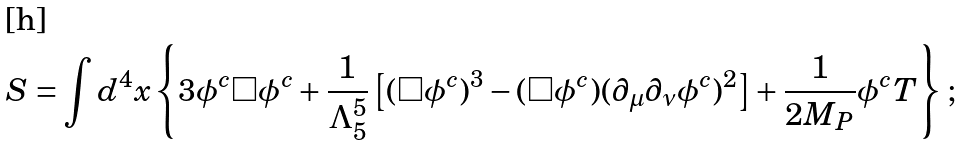<formula> <loc_0><loc_0><loc_500><loc_500>S = \int d ^ { 4 } x \left \{ 3 \phi ^ { c } \Box \phi ^ { c } + \frac { 1 } { \Lambda _ { 5 } ^ { 5 } } \left [ ( \Box \phi ^ { c } ) ^ { 3 } - ( \Box \phi ^ { c } ) ( \partial _ { \mu } \partial _ { \nu } \phi ^ { c } ) ^ { 2 } \right ] + \frac { 1 } { 2 M _ { P } } \phi ^ { c } T \right \} \, ;</formula> 